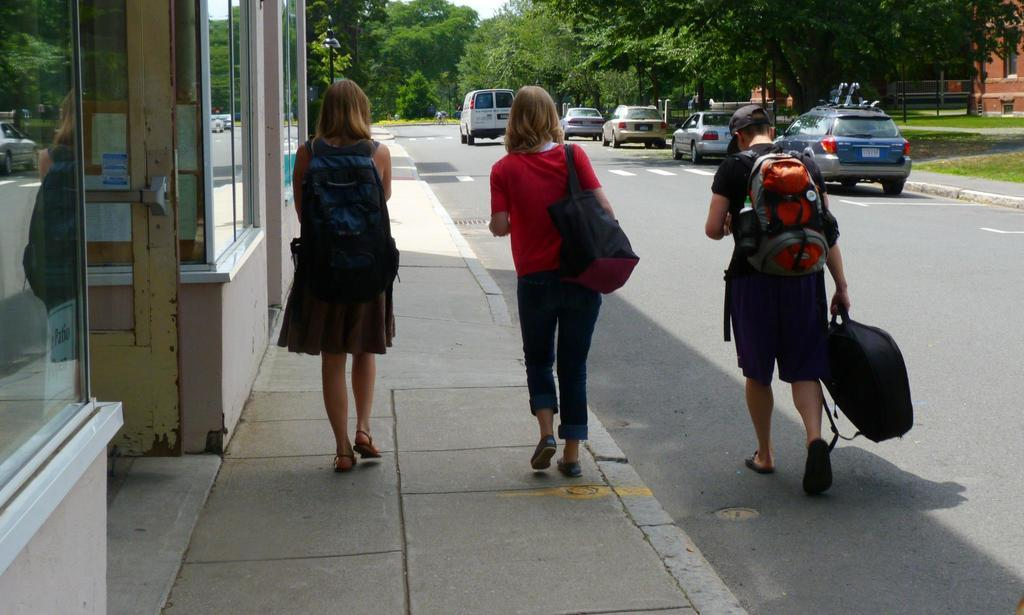How many people are in the image? There are three people in the image. What are the people doing in the image? The people are walking. What are the people wearing that might be used for carrying items? The people are wearing bags. What can be seen in the background of the image? There are cars, trees, and buildings in the background of the image. What type of quartz can be seen in the image? There is no quartz present in the image. How does the key help the people in the image? There is no key mentioned in the image, so it cannot help the people in any way. 